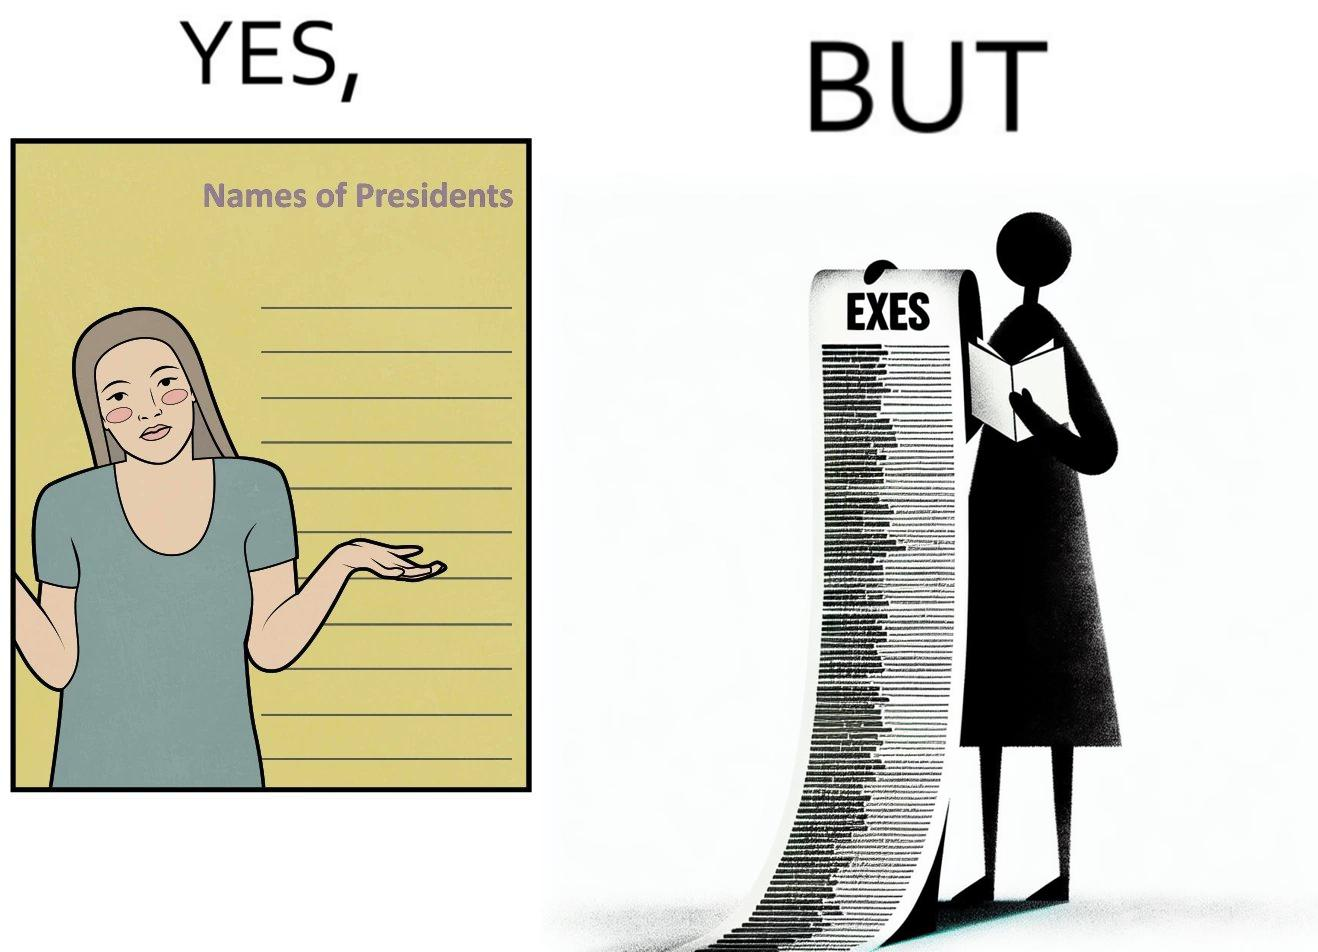Is this image satirical or non-satirical? Yes, this image is satirical. 